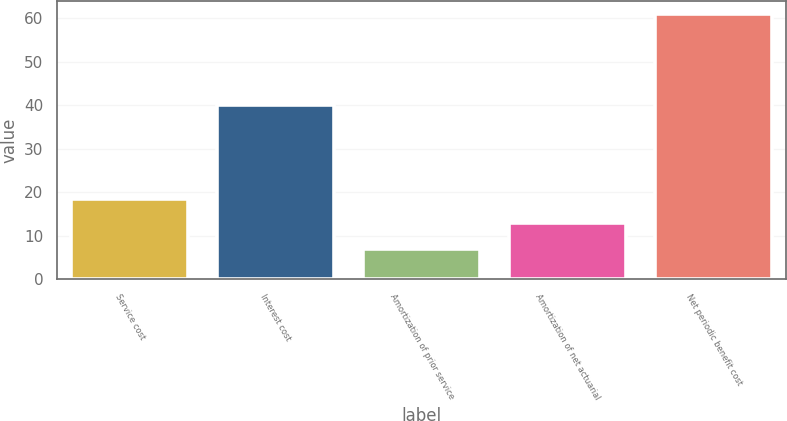Convert chart to OTSL. <chart><loc_0><loc_0><loc_500><loc_500><bar_chart><fcel>Service cost<fcel>Interest cost<fcel>Amortization of prior service<fcel>Amortization of net actuarial<fcel>Net periodic benefit cost<nl><fcel>18.4<fcel>40<fcel>7<fcel>13<fcel>61<nl></chart> 